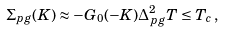<formula> <loc_0><loc_0><loc_500><loc_500>\Sigma _ { p g } ( K ) \approx - G _ { 0 } ( - K ) \Delta _ { p g } ^ { 2 } T \leq T _ { c } \, ,</formula> 